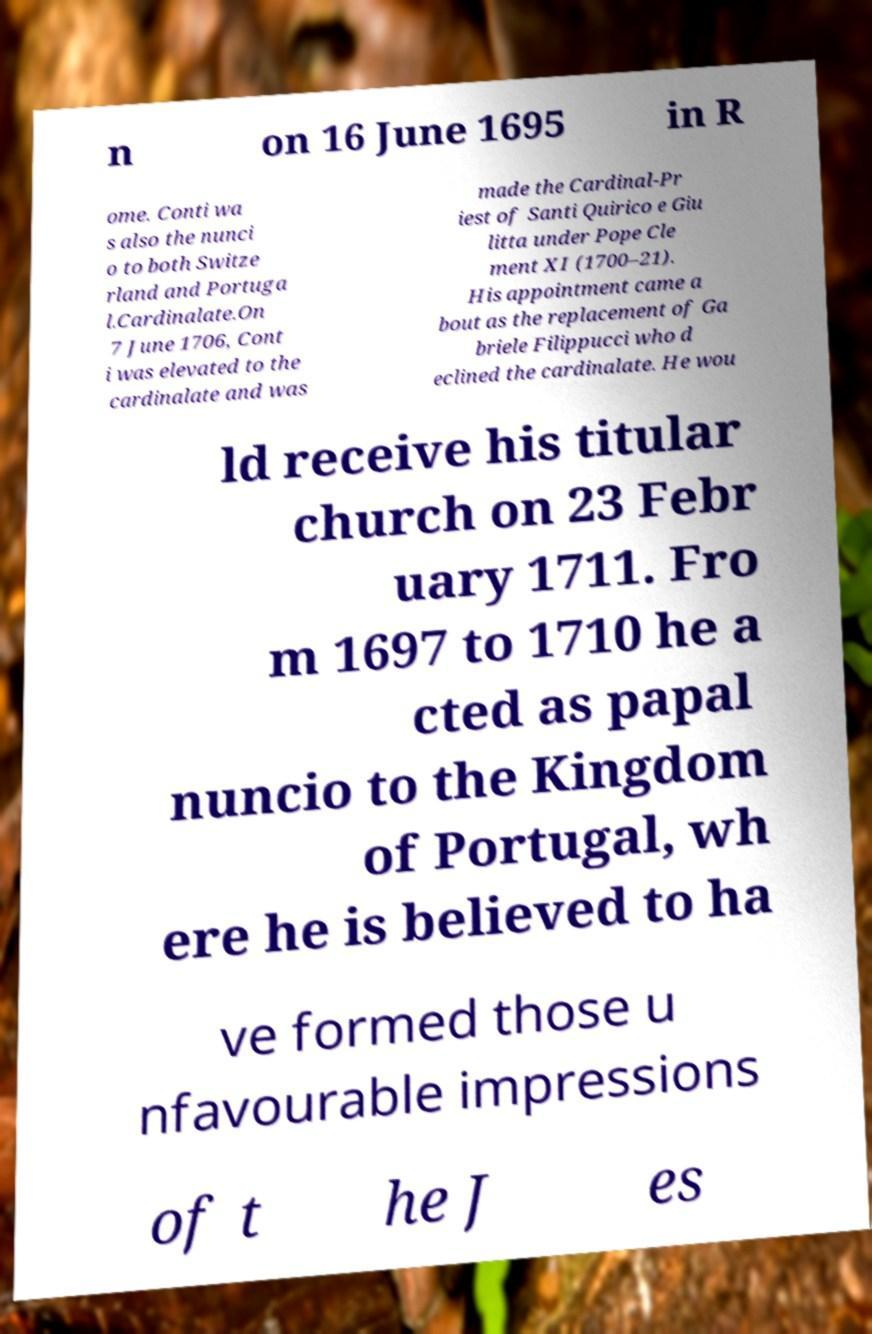Could you extract and type out the text from this image? n on 16 June 1695 in R ome. Conti wa s also the nunci o to both Switze rland and Portuga l.Cardinalate.On 7 June 1706, Cont i was elevated to the cardinalate and was made the Cardinal-Pr iest of Santi Quirico e Giu litta under Pope Cle ment XI (1700–21). His appointment came a bout as the replacement of Ga briele Filippucci who d eclined the cardinalate. He wou ld receive his titular church on 23 Febr uary 1711. Fro m 1697 to 1710 he a cted as papal nuncio to the Kingdom of Portugal, wh ere he is believed to ha ve formed those u nfavourable impressions of t he J es 